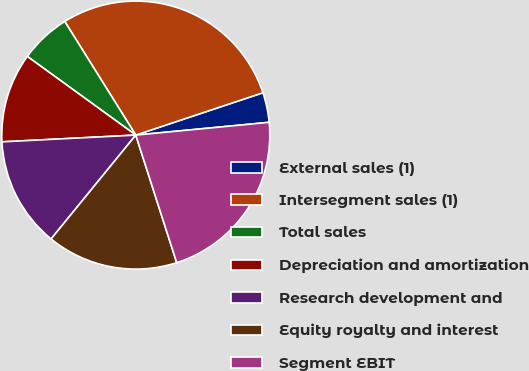<chart> <loc_0><loc_0><loc_500><loc_500><pie_chart><fcel>External sales (1)<fcel>Intersegment sales (1)<fcel>Total sales<fcel>Depreciation and amortization<fcel>Research development and<fcel>Equity royalty and interest<fcel>Segment EBIT<nl><fcel>3.6%<fcel>28.78%<fcel>6.12%<fcel>10.79%<fcel>13.31%<fcel>15.83%<fcel>21.58%<nl></chart> 